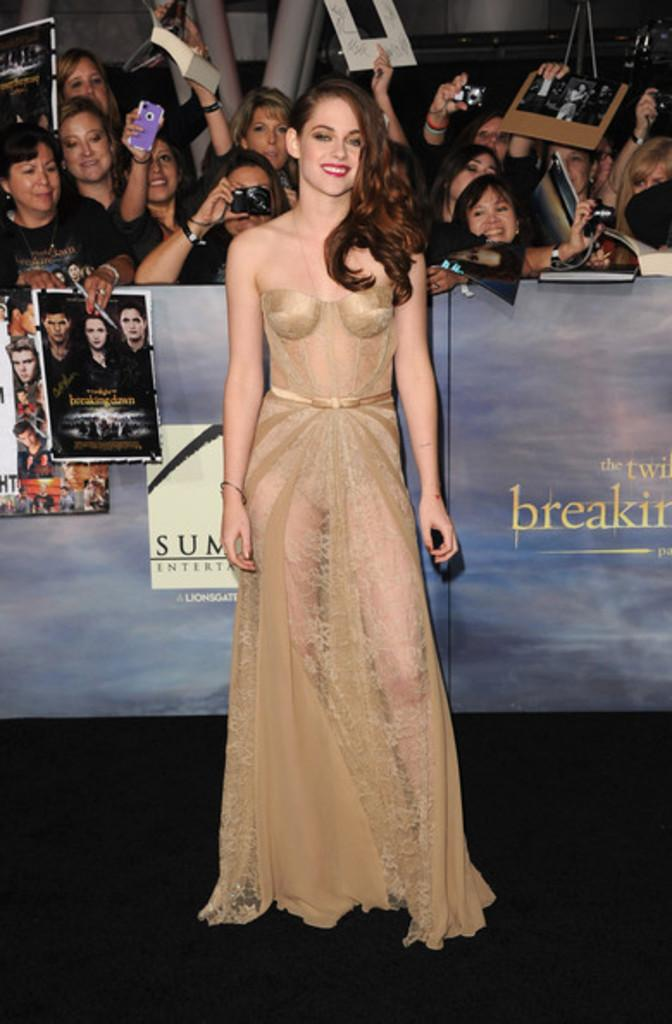Who is the main subject in the image? There is a woman in the image. What is the woman's position in the image? The woman is on the ground. What can be seen in the background of the image? There are boards, posters, people, and some objects in the background of the image. What type of scarf is the woman wearing in the image? There is no scarf visible on the woman in the image. What is the process for ordering the items seen in the background of the image? There is no indication of ordering or purchasing items in the image; it simply shows a woman on the ground and various elements in the background. 